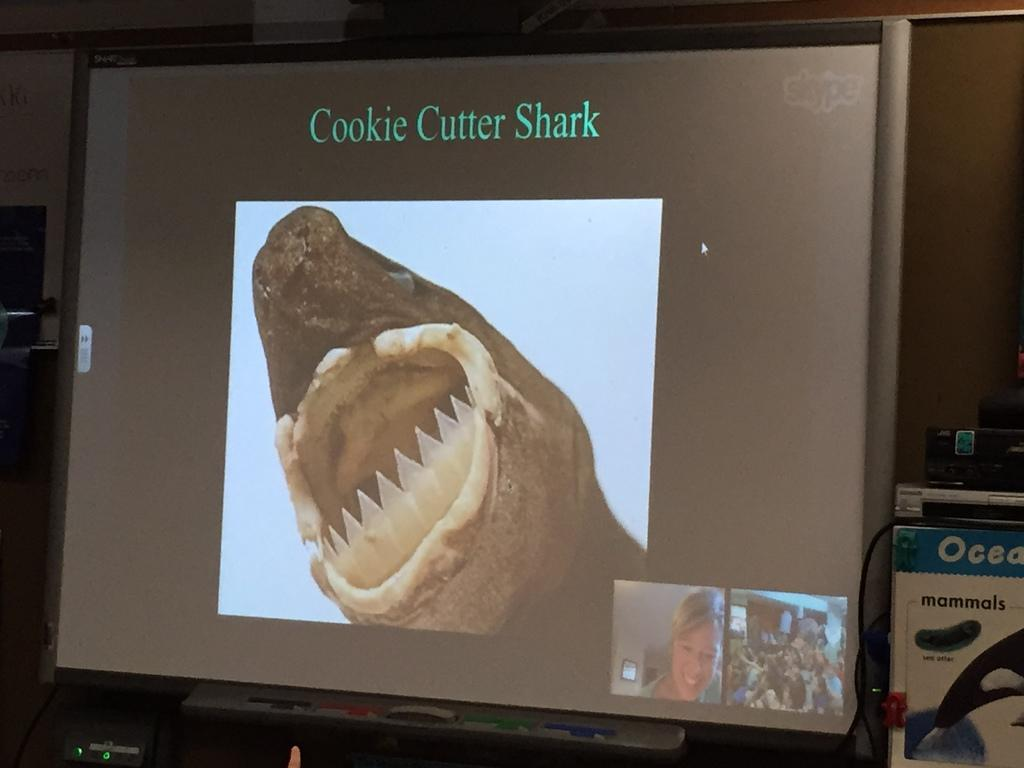<image>
Render a clear and concise summary of the photo. a screen with the word cookie on it 